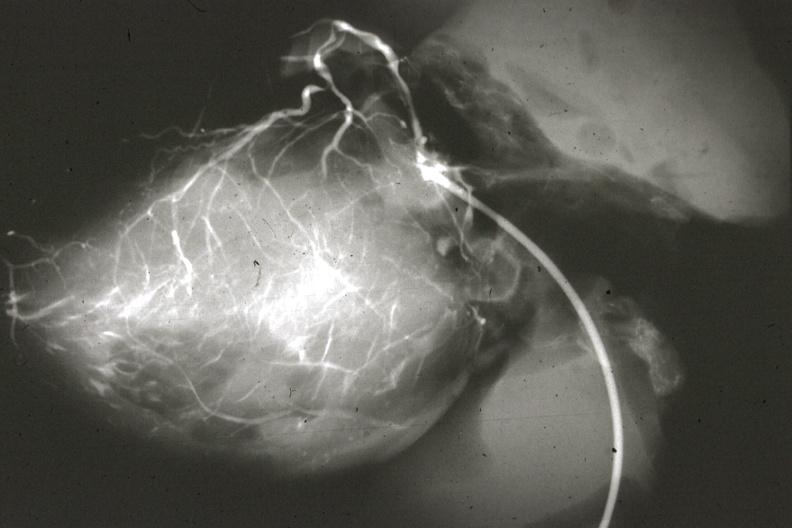s intraductal papillomatosis with apocrine metaplasia present?
Answer the question using a single word or phrase. No 